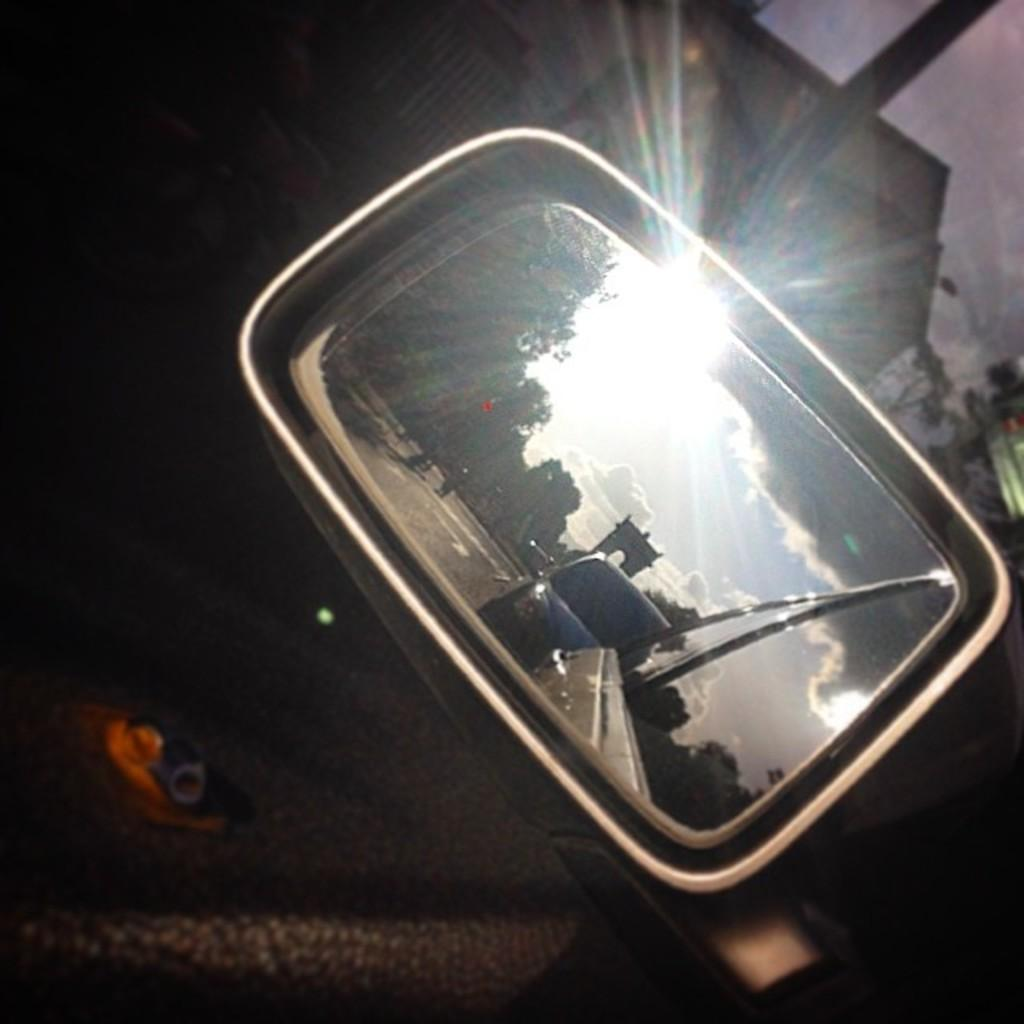What object is the main focus of the image? The main focus of the image is a side mirror. What can be seen in the side mirror's reflection? The side mirror has reflections in the image. What type of setting is visible in the background of the image? There is a road, a house, a pole, a tree, and the sky visible in the background of the image. What flavor of ice cream is being enjoyed by the person in the image? There is no person or ice cream present in the image; it features a side mirror with reflections and a background setting. 